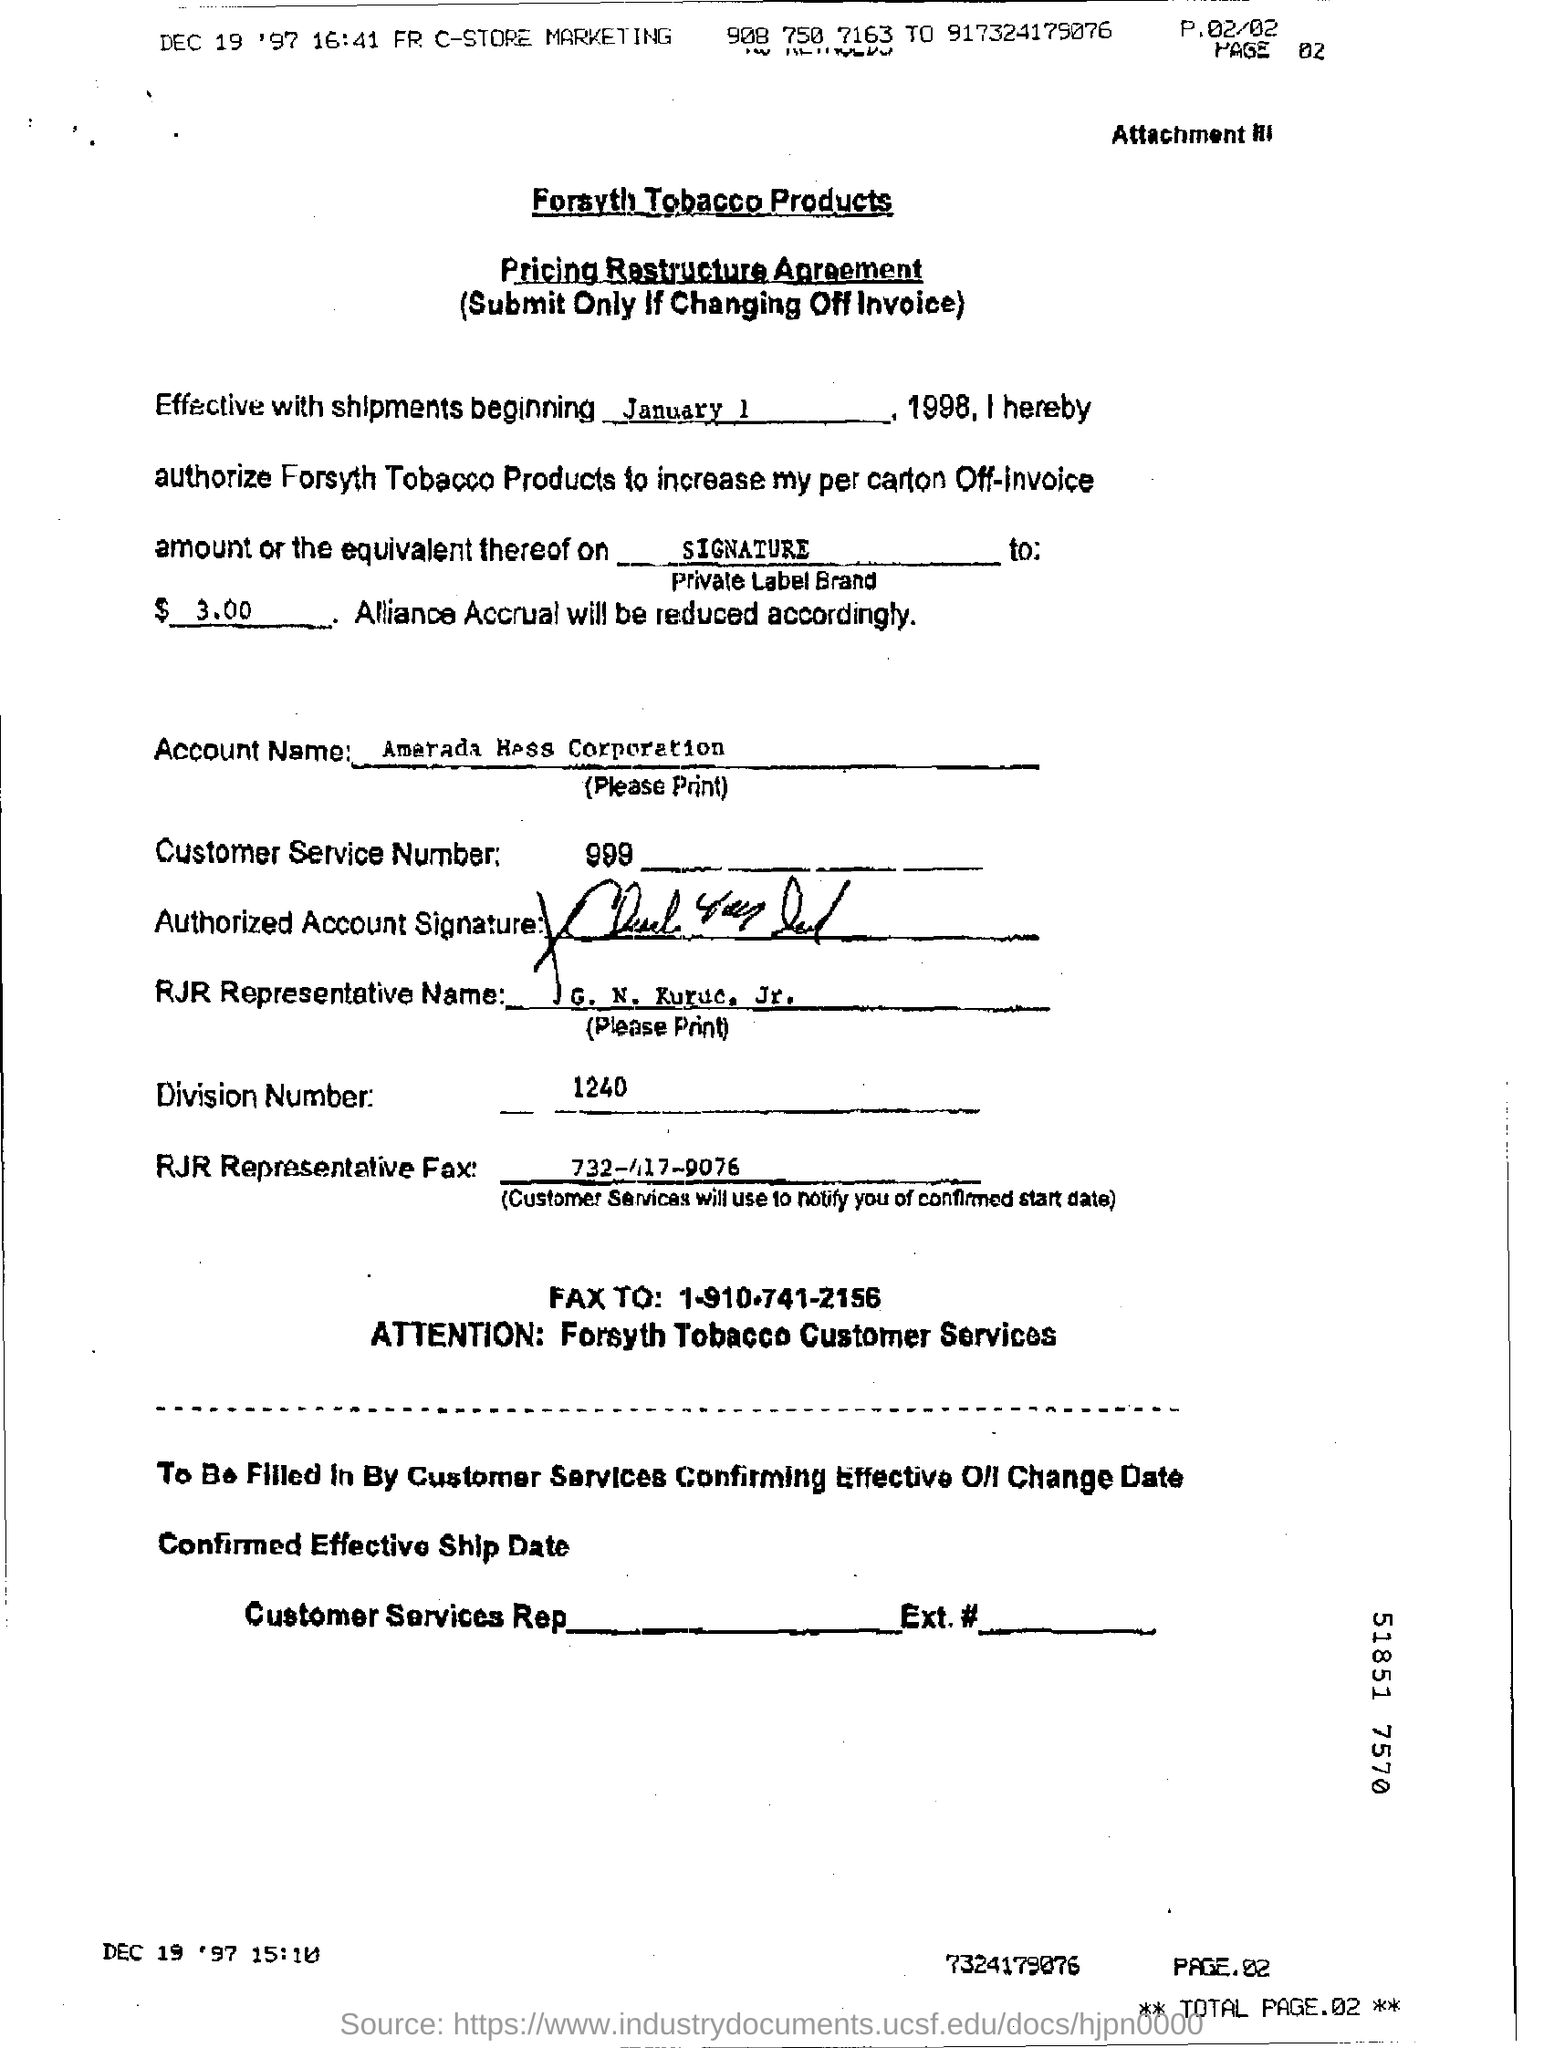What is the product name ?
Ensure brevity in your answer.  Forsyth Tobacco Products. What is the custom service number ?
Your answer should be very brief. 999. What is the agreement about ?
Your answer should be compact. Pricing Restructure. What is division number ?
Provide a succinct answer. 1240. When does shipping begin?
Ensure brevity in your answer.  January 1 1998. 